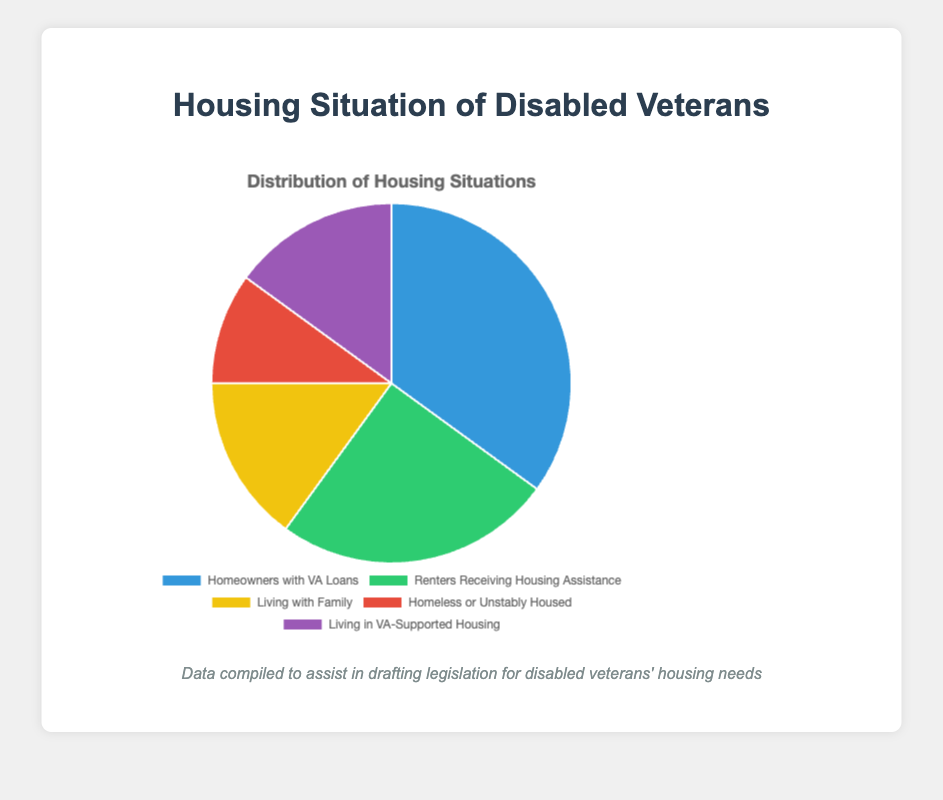What percentage of disabled veterans are homeowners with VA Loans? By looking at the chart, the segment for "Homeowners with VA Loans" is labeled with its percentage.
Answer: 35% How many categories have an equal percentage of disabled veterans? By observing the chart, "Living with Family" and "Living in VA-Supported Housing" both have the same percentage value of 15%.
Answer: 2 Which category has the least representation among disabled veterans' housing situations? Identifying the smallest segment in the pie chart, "Homeless or Unstably Housed" has the lowest percentage at 10%.
Answer: Homeless or Unstably Housed What is the sum of the percentages of veterans living with family and those in VA-supported housing? The percentage for "Living with Family" is 15%, and for "Living in VA-Supported Housing" it's also 15%. Adding these together: 15% + 15% = 30%.
Answer: 30% Are there more disabled veterans who are homeowners with VA Loans or those who live with family and in VA-supported housing combined? By adding the percentages for living with family and VA-supported housing, 15% + 15% = 30%. "Homeowners with VA Loans" is 35%. Since 35% is greater than 30%, there are more veterans who are homeowners with VA loans.
Answer: Homeowners with VA Loans What percentage of disabled veterans are either renters receiving housing assistance or homeless/unstably housed? The pie chart indicates 25% for renters receiving housing assistance and 10% for homeless/unstably housed. Summing these gives: 25% + 10% = 35%.
Answer: 35% Which category is visually represented with a green color in the chart? Referring to the legend, "Renters Receiving Housing Assistance" is shown in green.
Answer: Renters Receiving Housing Assistance How does the percentage of homeowners with VA Loans compare to the percentage for renters receiving housing assistance? "Homeowners with VA Loans" is 35% while "Renters Receiving Housing Assistance" is 25%. Comparing these percentages, 35% is greater than 25%.
Answer: Homeowners with VA Loans have a higher percentage What's the difference in percentage between the largest and smallest categories? The largest category is "Homeowners with VA Loans" at 35%, and the smallest is "Homeless or Unstably Housed" at 10%. The difference is: 35% - 10% = 25%.
Answer: 25% 